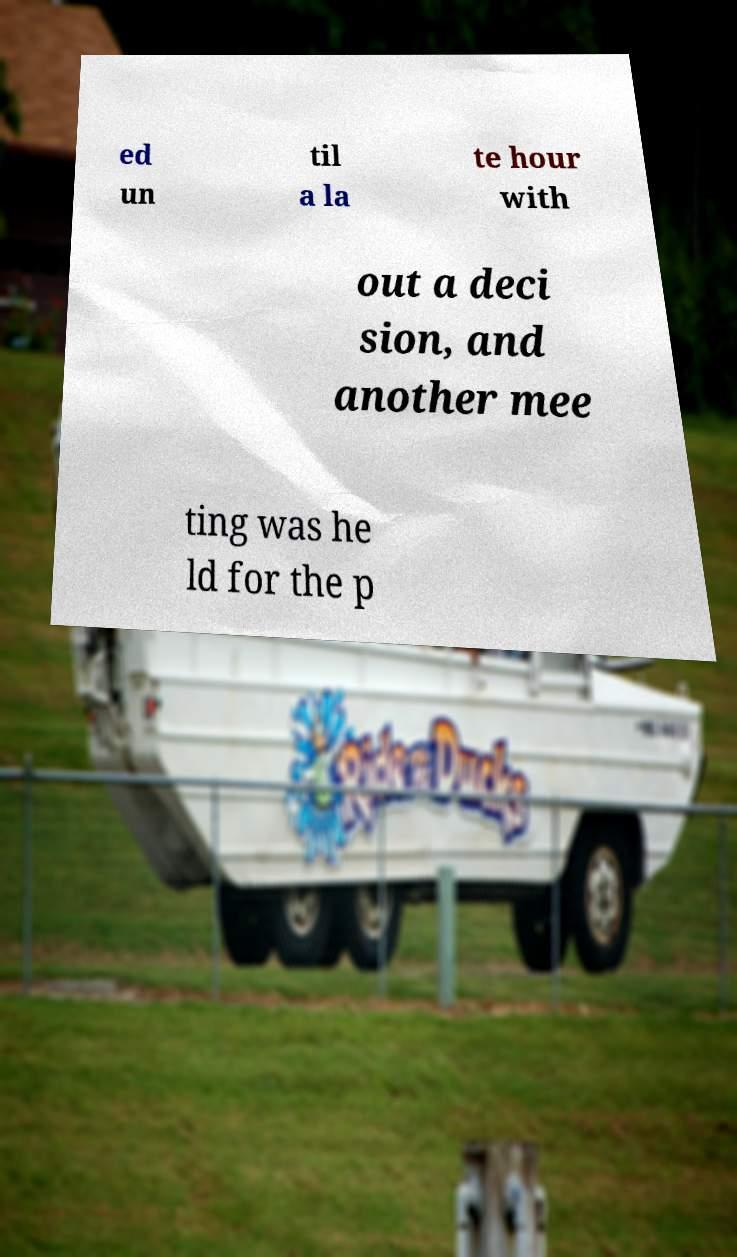Could you assist in decoding the text presented in this image and type it out clearly? ed un til a la te hour with out a deci sion, and another mee ting was he ld for the p 